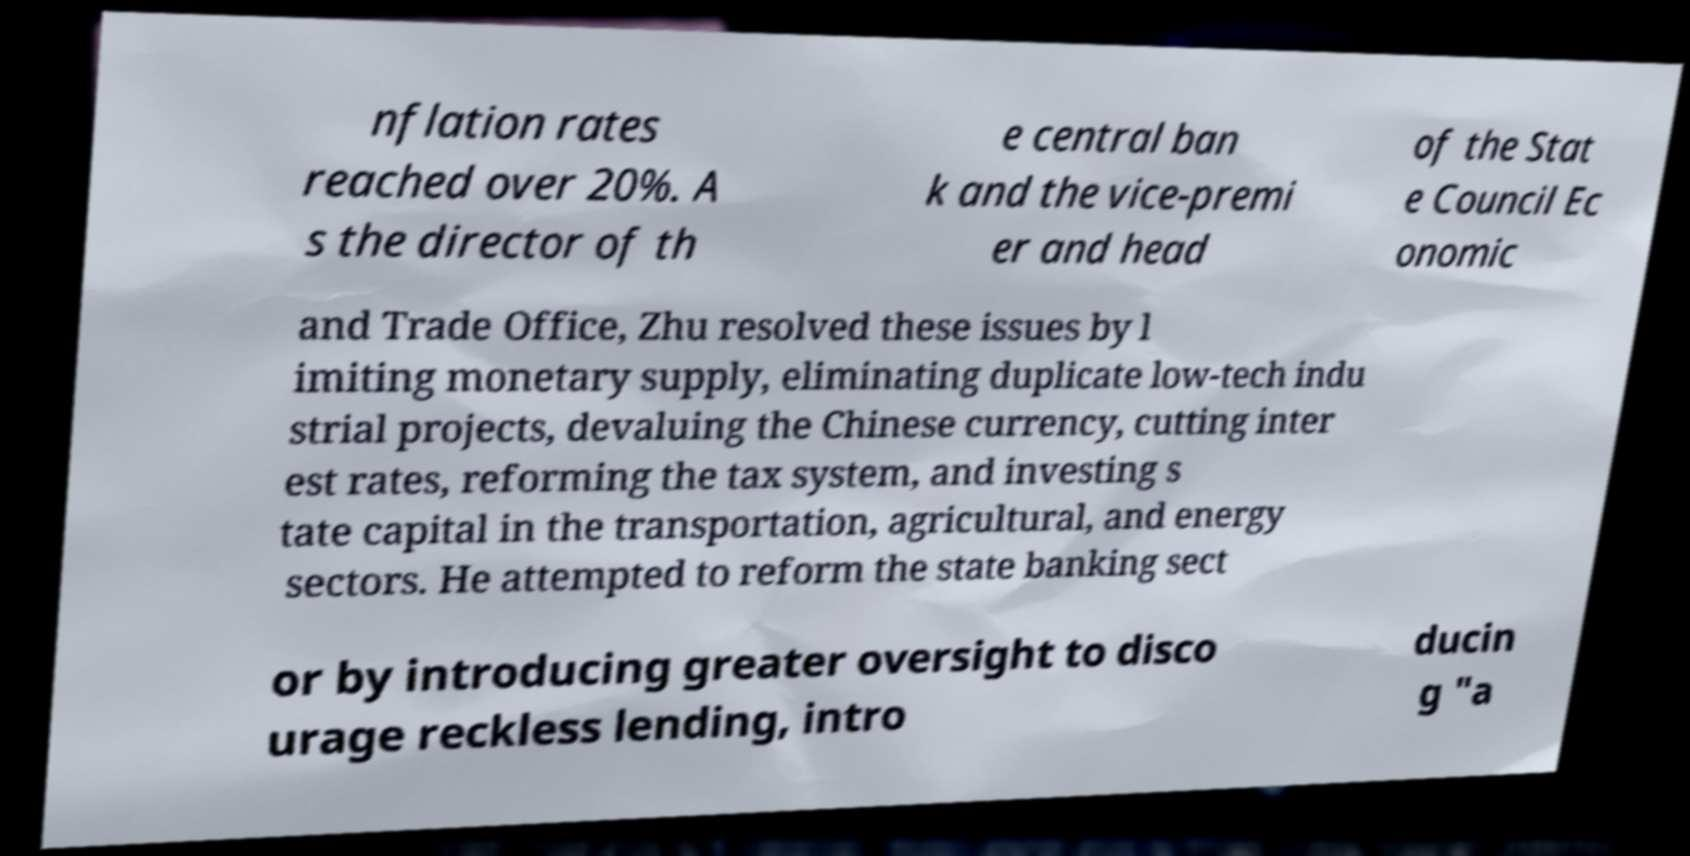For documentation purposes, I need the text within this image transcribed. Could you provide that? nflation rates reached over 20%. A s the director of th e central ban k and the vice-premi er and head of the Stat e Council Ec onomic and Trade Office, Zhu resolved these issues by l imiting monetary supply, eliminating duplicate low-tech indu strial projects, devaluing the Chinese currency, cutting inter est rates, reforming the tax system, and investing s tate capital in the transportation, agricultural, and energy sectors. He attempted to reform the state banking sect or by introducing greater oversight to disco urage reckless lending, intro ducin g "a 